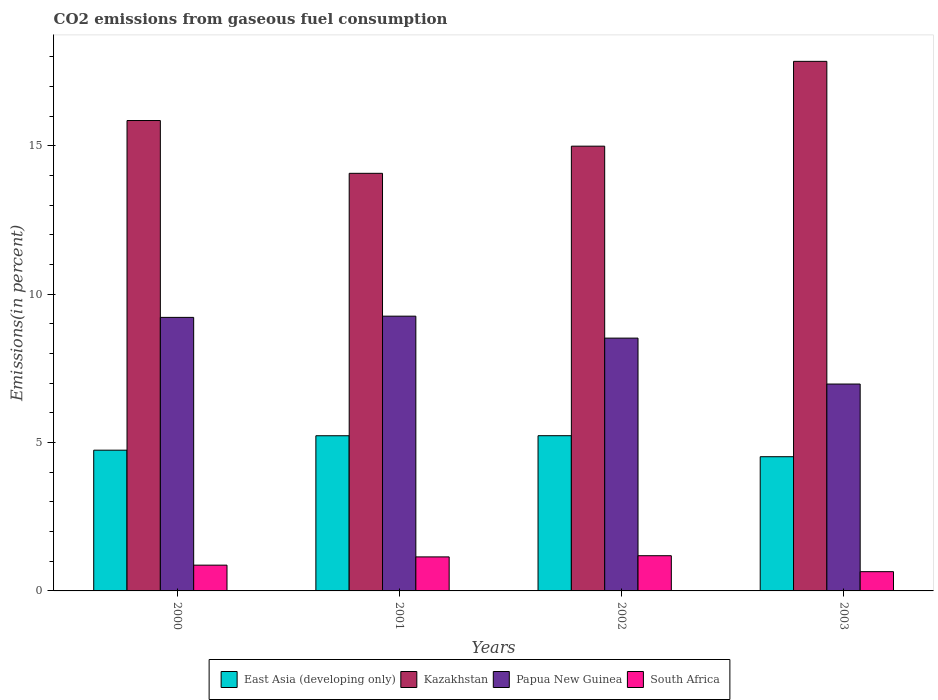How many groups of bars are there?
Make the answer very short. 4. Are the number of bars per tick equal to the number of legend labels?
Ensure brevity in your answer.  Yes. Are the number of bars on each tick of the X-axis equal?
Provide a succinct answer. Yes. What is the label of the 4th group of bars from the left?
Provide a succinct answer. 2003. What is the total CO2 emitted in South Africa in 2002?
Your answer should be compact. 1.19. Across all years, what is the maximum total CO2 emitted in East Asia (developing only)?
Your answer should be compact. 5.23. Across all years, what is the minimum total CO2 emitted in Papua New Guinea?
Ensure brevity in your answer.  6.97. In which year was the total CO2 emitted in East Asia (developing only) maximum?
Your response must be concise. 2002. In which year was the total CO2 emitted in South Africa minimum?
Your response must be concise. 2003. What is the total total CO2 emitted in Kazakhstan in the graph?
Your answer should be very brief. 62.74. What is the difference between the total CO2 emitted in East Asia (developing only) in 2002 and that in 2003?
Your answer should be very brief. 0.71. What is the difference between the total CO2 emitted in Kazakhstan in 2003 and the total CO2 emitted in Papua New Guinea in 2001?
Keep it short and to the point. 8.58. What is the average total CO2 emitted in South Africa per year?
Keep it short and to the point. 0.96. In the year 2003, what is the difference between the total CO2 emitted in Papua New Guinea and total CO2 emitted in East Asia (developing only)?
Your answer should be very brief. 2.45. What is the ratio of the total CO2 emitted in Papua New Guinea in 2001 to that in 2003?
Offer a very short reply. 1.33. Is the difference between the total CO2 emitted in Papua New Guinea in 2001 and 2003 greater than the difference between the total CO2 emitted in East Asia (developing only) in 2001 and 2003?
Your response must be concise. Yes. What is the difference between the highest and the second highest total CO2 emitted in South Africa?
Give a very brief answer. 0.04. What is the difference between the highest and the lowest total CO2 emitted in Papua New Guinea?
Offer a very short reply. 2.29. Is it the case that in every year, the sum of the total CO2 emitted in East Asia (developing only) and total CO2 emitted in Papua New Guinea is greater than the sum of total CO2 emitted in Kazakhstan and total CO2 emitted in South Africa?
Offer a terse response. Yes. What does the 3rd bar from the left in 2001 represents?
Offer a very short reply. Papua New Guinea. What does the 4th bar from the right in 2003 represents?
Offer a terse response. East Asia (developing only). How many bars are there?
Keep it short and to the point. 16. Are all the bars in the graph horizontal?
Make the answer very short. No. How many years are there in the graph?
Provide a succinct answer. 4. Does the graph contain any zero values?
Offer a terse response. No. How many legend labels are there?
Give a very brief answer. 4. What is the title of the graph?
Offer a very short reply. CO2 emissions from gaseous fuel consumption. What is the label or title of the X-axis?
Your answer should be compact. Years. What is the label or title of the Y-axis?
Offer a very short reply. Emissions(in percent). What is the Emissions(in percent) of East Asia (developing only) in 2000?
Make the answer very short. 4.74. What is the Emissions(in percent) in Kazakhstan in 2000?
Offer a very short reply. 15.85. What is the Emissions(in percent) of Papua New Guinea in 2000?
Ensure brevity in your answer.  9.22. What is the Emissions(in percent) of South Africa in 2000?
Give a very brief answer. 0.87. What is the Emissions(in percent) of East Asia (developing only) in 2001?
Ensure brevity in your answer.  5.23. What is the Emissions(in percent) in Kazakhstan in 2001?
Keep it short and to the point. 14.07. What is the Emissions(in percent) in Papua New Guinea in 2001?
Ensure brevity in your answer.  9.26. What is the Emissions(in percent) in South Africa in 2001?
Give a very brief answer. 1.15. What is the Emissions(in percent) of East Asia (developing only) in 2002?
Provide a succinct answer. 5.23. What is the Emissions(in percent) in Kazakhstan in 2002?
Ensure brevity in your answer.  14.98. What is the Emissions(in percent) of Papua New Guinea in 2002?
Your answer should be very brief. 8.52. What is the Emissions(in percent) in South Africa in 2002?
Offer a very short reply. 1.19. What is the Emissions(in percent) in East Asia (developing only) in 2003?
Keep it short and to the point. 4.52. What is the Emissions(in percent) of Kazakhstan in 2003?
Make the answer very short. 17.84. What is the Emissions(in percent) in Papua New Guinea in 2003?
Give a very brief answer. 6.97. What is the Emissions(in percent) in South Africa in 2003?
Your answer should be very brief. 0.65. Across all years, what is the maximum Emissions(in percent) in East Asia (developing only)?
Keep it short and to the point. 5.23. Across all years, what is the maximum Emissions(in percent) of Kazakhstan?
Provide a succinct answer. 17.84. Across all years, what is the maximum Emissions(in percent) of Papua New Guinea?
Provide a succinct answer. 9.26. Across all years, what is the maximum Emissions(in percent) in South Africa?
Provide a succinct answer. 1.19. Across all years, what is the minimum Emissions(in percent) of East Asia (developing only)?
Give a very brief answer. 4.52. Across all years, what is the minimum Emissions(in percent) of Kazakhstan?
Ensure brevity in your answer.  14.07. Across all years, what is the minimum Emissions(in percent) in Papua New Guinea?
Offer a terse response. 6.97. Across all years, what is the minimum Emissions(in percent) in South Africa?
Provide a short and direct response. 0.65. What is the total Emissions(in percent) in East Asia (developing only) in the graph?
Offer a terse response. 19.72. What is the total Emissions(in percent) of Kazakhstan in the graph?
Give a very brief answer. 62.74. What is the total Emissions(in percent) of Papua New Guinea in the graph?
Provide a succinct answer. 33.96. What is the total Emissions(in percent) in South Africa in the graph?
Provide a short and direct response. 3.85. What is the difference between the Emissions(in percent) of East Asia (developing only) in 2000 and that in 2001?
Provide a succinct answer. -0.49. What is the difference between the Emissions(in percent) of Kazakhstan in 2000 and that in 2001?
Keep it short and to the point. 1.78. What is the difference between the Emissions(in percent) of Papua New Guinea in 2000 and that in 2001?
Your answer should be very brief. -0.04. What is the difference between the Emissions(in percent) in South Africa in 2000 and that in 2001?
Offer a very short reply. -0.28. What is the difference between the Emissions(in percent) of East Asia (developing only) in 2000 and that in 2002?
Your answer should be compact. -0.49. What is the difference between the Emissions(in percent) in Kazakhstan in 2000 and that in 2002?
Provide a short and direct response. 0.86. What is the difference between the Emissions(in percent) in Papua New Guinea in 2000 and that in 2002?
Give a very brief answer. 0.7. What is the difference between the Emissions(in percent) of South Africa in 2000 and that in 2002?
Your answer should be very brief. -0.32. What is the difference between the Emissions(in percent) of East Asia (developing only) in 2000 and that in 2003?
Give a very brief answer. 0.22. What is the difference between the Emissions(in percent) of Kazakhstan in 2000 and that in 2003?
Offer a very short reply. -1.99. What is the difference between the Emissions(in percent) in Papua New Guinea in 2000 and that in 2003?
Provide a short and direct response. 2.25. What is the difference between the Emissions(in percent) in South Africa in 2000 and that in 2003?
Ensure brevity in your answer.  0.22. What is the difference between the Emissions(in percent) of East Asia (developing only) in 2001 and that in 2002?
Your answer should be compact. -0. What is the difference between the Emissions(in percent) in Kazakhstan in 2001 and that in 2002?
Offer a terse response. -0.91. What is the difference between the Emissions(in percent) in Papua New Guinea in 2001 and that in 2002?
Your answer should be compact. 0.74. What is the difference between the Emissions(in percent) in South Africa in 2001 and that in 2002?
Your answer should be very brief. -0.04. What is the difference between the Emissions(in percent) of East Asia (developing only) in 2001 and that in 2003?
Your answer should be very brief. 0.71. What is the difference between the Emissions(in percent) in Kazakhstan in 2001 and that in 2003?
Your answer should be very brief. -3.77. What is the difference between the Emissions(in percent) of Papua New Guinea in 2001 and that in 2003?
Your answer should be very brief. 2.29. What is the difference between the Emissions(in percent) in South Africa in 2001 and that in 2003?
Your response must be concise. 0.5. What is the difference between the Emissions(in percent) in East Asia (developing only) in 2002 and that in 2003?
Your answer should be compact. 0.71. What is the difference between the Emissions(in percent) of Kazakhstan in 2002 and that in 2003?
Keep it short and to the point. -2.86. What is the difference between the Emissions(in percent) in Papua New Guinea in 2002 and that in 2003?
Your response must be concise. 1.55. What is the difference between the Emissions(in percent) of South Africa in 2002 and that in 2003?
Provide a succinct answer. 0.54. What is the difference between the Emissions(in percent) of East Asia (developing only) in 2000 and the Emissions(in percent) of Kazakhstan in 2001?
Your answer should be very brief. -9.33. What is the difference between the Emissions(in percent) of East Asia (developing only) in 2000 and the Emissions(in percent) of Papua New Guinea in 2001?
Your answer should be very brief. -4.52. What is the difference between the Emissions(in percent) in East Asia (developing only) in 2000 and the Emissions(in percent) in South Africa in 2001?
Give a very brief answer. 3.6. What is the difference between the Emissions(in percent) of Kazakhstan in 2000 and the Emissions(in percent) of Papua New Guinea in 2001?
Keep it short and to the point. 6.59. What is the difference between the Emissions(in percent) of Kazakhstan in 2000 and the Emissions(in percent) of South Africa in 2001?
Provide a short and direct response. 14.7. What is the difference between the Emissions(in percent) in Papua New Guinea in 2000 and the Emissions(in percent) in South Africa in 2001?
Give a very brief answer. 8.07. What is the difference between the Emissions(in percent) in East Asia (developing only) in 2000 and the Emissions(in percent) in Kazakhstan in 2002?
Your response must be concise. -10.24. What is the difference between the Emissions(in percent) of East Asia (developing only) in 2000 and the Emissions(in percent) of Papua New Guinea in 2002?
Offer a very short reply. -3.78. What is the difference between the Emissions(in percent) in East Asia (developing only) in 2000 and the Emissions(in percent) in South Africa in 2002?
Offer a very short reply. 3.56. What is the difference between the Emissions(in percent) of Kazakhstan in 2000 and the Emissions(in percent) of Papua New Guinea in 2002?
Your answer should be very brief. 7.33. What is the difference between the Emissions(in percent) in Kazakhstan in 2000 and the Emissions(in percent) in South Africa in 2002?
Offer a very short reply. 14.66. What is the difference between the Emissions(in percent) of Papua New Guinea in 2000 and the Emissions(in percent) of South Africa in 2002?
Provide a short and direct response. 8.03. What is the difference between the Emissions(in percent) in East Asia (developing only) in 2000 and the Emissions(in percent) in Papua New Guinea in 2003?
Your response must be concise. -2.23. What is the difference between the Emissions(in percent) in East Asia (developing only) in 2000 and the Emissions(in percent) in South Africa in 2003?
Ensure brevity in your answer.  4.09. What is the difference between the Emissions(in percent) in Kazakhstan in 2000 and the Emissions(in percent) in Papua New Guinea in 2003?
Give a very brief answer. 8.88. What is the difference between the Emissions(in percent) of Kazakhstan in 2000 and the Emissions(in percent) of South Africa in 2003?
Your answer should be very brief. 15.2. What is the difference between the Emissions(in percent) of Papua New Guinea in 2000 and the Emissions(in percent) of South Africa in 2003?
Your answer should be very brief. 8.57. What is the difference between the Emissions(in percent) of East Asia (developing only) in 2001 and the Emissions(in percent) of Kazakhstan in 2002?
Provide a short and direct response. -9.76. What is the difference between the Emissions(in percent) in East Asia (developing only) in 2001 and the Emissions(in percent) in Papua New Guinea in 2002?
Provide a succinct answer. -3.29. What is the difference between the Emissions(in percent) in East Asia (developing only) in 2001 and the Emissions(in percent) in South Africa in 2002?
Your response must be concise. 4.04. What is the difference between the Emissions(in percent) of Kazakhstan in 2001 and the Emissions(in percent) of Papua New Guinea in 2002?
Your response must be concise. 5.55. What is the difference between the Emissions(in percent) of Kazakhstan in 2001 and the Emissions(in percent) of South Africa in 2002?
Your response must be concise. 12.88. What is the difference between the Emissions(in percent) of Papua New Guinea in 2001 and the Emissions(in percent) of South Africa in 2002?
Offer a very short reply. 8.07. What is the difference between the Emissions(in percent) in East Asia (developing only) in 2001 and the Emissions(in percent) in Kazakhstan in 2003?
Provide a succinct answer. -12.61. What is the difference between the Emissions(in percent) of East Asia (developing only) in 2001 and the Emissions(in percent) of Papua New Guinea in 2003?
Keep it short and to the point. -1.74. What is the difference between the Emissions(in percent) of East Asia (developing only) in 2001 and the Emissions(in percent) of South Africa in 2003?
Offer a terse response. 4.58. What is the difference between the Emissions(in percent) of Kazakhstan in 2001 and the Emissions(in percent) of Papua New Guinea in 2003?
Offer a very short reply. 7.1. What is the difference between the Emissions(in percent) of Kazakhstan in 2001 and the Emissions(in percent) of South Africa in 2003?
Your response must be concise. 13.42. What is the difference between the Emissions(in percent) of Papua New Guinea in 2001 and the Emissions(in percent) of South Africa in 2003?
Offer a terse response. 8.61. What is the difference between the Emissions(in percent) of East Asia (developing only) in 2002 and the Emissions(in percent) of Kazakhstan in 2003?
Offer a very short reply. -12.61. What is the difference between the Emissions(in percent) of East Asia (developing only) in 2002 and the Emissions(in percent) of Papua New Guinea in 2003?
Your response must be concise. -1.74. What is the difference between the Emissions(in percent) of East Asia (developing only) in 2002 and the Emissions(in percent) of South Africa in 2003?
Ensure brevity in your answer.  4.58. What is the difference between the Emissions(in percent) of Kazakhstan in 2002 and the Emissions(in percent) of Papua New Guinea in 2003?
Offer a terse response. 8.01. What is the difference between the Emissions(in percent) in Kazakhstan in 2002 and the Emissions(in percent) in South Africa in 2003?
Offer a very short reply. 14.34. What is the difference between the Emissions(in percent) in Papua New Guinea in 2002 and the Emissions(in percent) in South Africa in 2003?
Keep it short and to the point. 7.87. What is the average Emissions(in percent) in East Asia (developing only) per year?
Make the answer very short. 4.93. What is the average Emissions(in percent) in Kazakhstan per year?
Ensure brevity in your answer.  15.69. What is the average Emissions(in percent) of Papua New Guinea per year?
Keep it short and to the point. 8.49. What is the average Emissions(in percent) of South Africa per year?
Your answer should be compact. 0.96. In the year 2000, what is the difference between the Emissions(in percent) in East Asia (developing only) and Emissions(in percent) in Kazakhstan?
Keep it short and to the point. -11.11. In the year 2000, what is the difference between the Emissions(in percent) of East Asia (developing only) and Emissions(in percent) of Papua New Guinea?
Make the answer very short. -4.47. In the year 2000, what is the difference between the Emissions(in percent) of East Asia (developing only) and Emissions(in percent) of South Africa?
Make the answer very short. 3.87. In the year 2000, what is the difference between the Emissions(in percent) in Kazakhstan and Emissions(in percent) in Papua New Guinea?
Your answer should be compact. 6.63. In the year 2000, what is the difference between the Emissions(in percent) in Kazakhstan and Emissions(in percent) in South Africa?
Ensure brevity in your answer.  14.98. In the year 2000, what is the difference between the Emissions(in percent) of Papua New Guinea and Emissions(in percent) of South Africa?
Your answer should be very brief. 8.35. In the year 2001, what is the difference between the Emissions(in percent) of East Asia (developing only) and Emissions(in percent) of Kazakhstan?
Your answer should be very brief. -8.84. In the year 2001, what is the difference between the Emissions(in percent) of East Asia (developing only) and Emissions(in percent) of Papua New Guinea?
Your answer should be very brief. -4.03. In the year 2001, what is the difference between the Emissions(in percent) of East Asia (developing only) and Emissions(in percent) of South Africa?
Offer a very short reply. 4.08. In the year 2001, what is the difference between the Emissions(in percent) in Kazakhstan and Emissions(in percent) in Papua New Guinea?
Your answer should be compact. 4.81. In the year 2001, what is the difference between the Emissions(in percent) of Kazakhstan and Emissions(in percent) of South Africa?
Provide a succinct answer. 12.92. In the year 2001, what is the difference between the Emissions(in percent) in Papua New Guinea and Emissions(in percent) in South Africa?
Give a very brief answer. 8.11. In the year 2002, what is the difference between the Emissions(in percent) in East Asia (developing only) and Emissions(in percent) in Kazakhstan?
Your answer should be compact. -9.75. In the year 2002, what is the difference between the Emissions(in percent) of East Asia (developing only) and Emissions(in percent) of Papua New Guinea?
Provide a succinct answer. -3.29. In the year 2002, what is the difference between the Emissions(in percent) in East Asia (developing only) and Emissions(in percent) in South Africa?
Your answer should be very brief. 4.04. In the year 2002, what is the difference between the Emissions(in percent) in Kazakhstan and Emissions(in percent) in Papua New Guinea?
Offer a very short reply. 6.47. In the year 2002, what is the difference between the Emissions(in percent) in Kazakhstan and Emissions(in percent) in South Africa?
Provide a short and direct response. 13.8. In the year 2002, what is the difference between the Emissions(in percent) of Papua New Guinea and Emissions(in percent) of South Africa?
Your answer should be compact. 7.33. In the year 2003, what is the difference between the Emissions(in percent) in East Asia (developing only) and Emissions(in percent) in Kazakhstan?
Your response must be concise. -13.32. In the year 2003, what is the difference between the Emissions(in percent) of East Asia (developing only) and Emissions(in percent) of Papua New Guinea?
Ensure brevity in your answer.  -2.45. In the year 2003, what is the difference between the Emissions(in percent) in East Asia (developing only) and Emissions(in percent) in South Africa?
Keep it short and to the point. 3.87. In the year 2003, what is the difference between the Emissions(in percent) of Kazakhstan and Emissions(in percent) of Papua New Guinea?
Make the answer very short. 10.87. In the year 2003, what is the difference between the Emissions(in percent) of Kazakhstan and Emissions(in percent) of South Africa?
Give a very brief answer. 17.19. In the year 2003, what is the difference between the Emissions(in percent) of Papua New Guinea and Emissions(in percent) of South Africa?
Provide a short and direct response. 6.32. What is the ratio of the Emissions(in percent) in East Asia (developing only) in 2000 to that in 2001?
Offer a very short reply. 0.91. What is the ratio of the Emissions(in percent) in Kazakhstan in 2000 to that in 2001?
Your response must be concise. 1.13. What is the ratio of the Emissions(in percent) of Papua New Guinea in 2000 to that in 2001?
Provide a short and direct response. 1. What is the ratio of the Emissions(in percent) in South Africa in 2000 to that in 2001?
Give a very brief answer. 0.76. What is the ratio of the Emissions(in percent) of East Asia (developing only) in 2000 to that in 2002?
Your answer should be very brief. 0.91. What is the ratio of the Emissions(in percent) in Kazakhstan in 2000 to that in 2002?
Offer a terse response. 1.06. What is the ratio of the Emissions(in percent) of Papua New Guinea in 2000 to that in 2002?
Provide a succinct answer. 1.08. What is the ratio of the Emissions(in percent) of South Africa in 2000 to that in 2002?
Offer a very short reply. 0.73. What is the ratio of the Emissions(in percent) in East Asia (developing only) in 2000 to that in 2003?
Ensure brevity in your answer.  1.05. What is the ratio of the Emissions(in percent) in Kazakhstan in 2000 to that in 2003?
Ensure brevity in your answer.  0.89. What is the ratio of the Emissions(in percent) in Papua New Guinea in 2000 to that in 2003?
Your answer should be very brief. 1.32. What is the ratio of the Emissions(in percent) in South Africa in 2000 to that in 2003?
Provide a succinct answer. 1.34. What is the ratio of the Emissions(in percent) of Kazakhstan in 2001 to that in 2002?
Your response must be concise. 0.94. What is the ratio of the Emissions(in percent) in Papua New Guinea in 2001 to that in 2002?
Offer a very short reply. 1.09. What is the ratio of the Emissions(in percent) in South Africa in 2001 to that in 2002?
Provide a succinct answer. 0.97. What is the ratio of the Emissions(in percent) in East Asia (developing only) in 2001 to that in 2003?
Your answer should be compact. 1.16. What is the ratio of the Emissions(in percent) of Kazakhstan in 2001 to that in 2003?
Your answer should be very brief. 0.79. What is the ratio of the Emissions(in percent) in Papua New Guinea in 2001 to that in 2003?
Your answer should be very brief. 1.33. What is the ratio of the Emissions(in percent) of South Africa in 2001 to that in 2003?
Your answer should be compact. 1.77. What is the ratio of the Emissions(in percent) of East Asia (developing only) in 2002 to that in 2003?
Provide a succinct answer. 1.16. What is the ratio of the Emissions(in percent) of Kazakhstan in 2002 to that in 2003?
Make the answer very short. 0.84. What is the ratio of the Emissions(in percent) in Papua New Guinea in 2002 to that in 2003?
Provide a short and direct response. 1.22. What is the ratio of the Emissions(in percent) in South Africa in 2002 to that in 2003?
Ensure brevity in your answer.  1.83. What is the difference between the highest and the second highest Emissions(in percent) in East Asia (developing only)?
Your answer should be compact. 0. What is the difference between the highest and the second highest Emissions(in percent) in Kazakhstan?
Provide a succinct answer. 1.99. What is the difference between the highest and the second highest Emissions(in percent) of Papua New Guinea?
Provide a succinct answer. 0.04. What is the difference between the highest and the second highest Emissions(in percent) of South Africa?
Give a very brief answer. 0.04. What is the difference between the highest and the lowest Emissions(in percent) of East Asia (developing only)?
Provide a succinct answer. 0.71. What is the difference between the highest and the lowest Emissions(in percent) of Kazakhstan?
Make the answer very short. 3.77. What is the difference between the highest and the lowest Emissions(in percent) in Papua New Guinea?
Provide a succinct answer. 2.29. What is the difference between the highest and the lowest Emissions(in percent) of South Africa?
Offer a terse response. 0.54. 